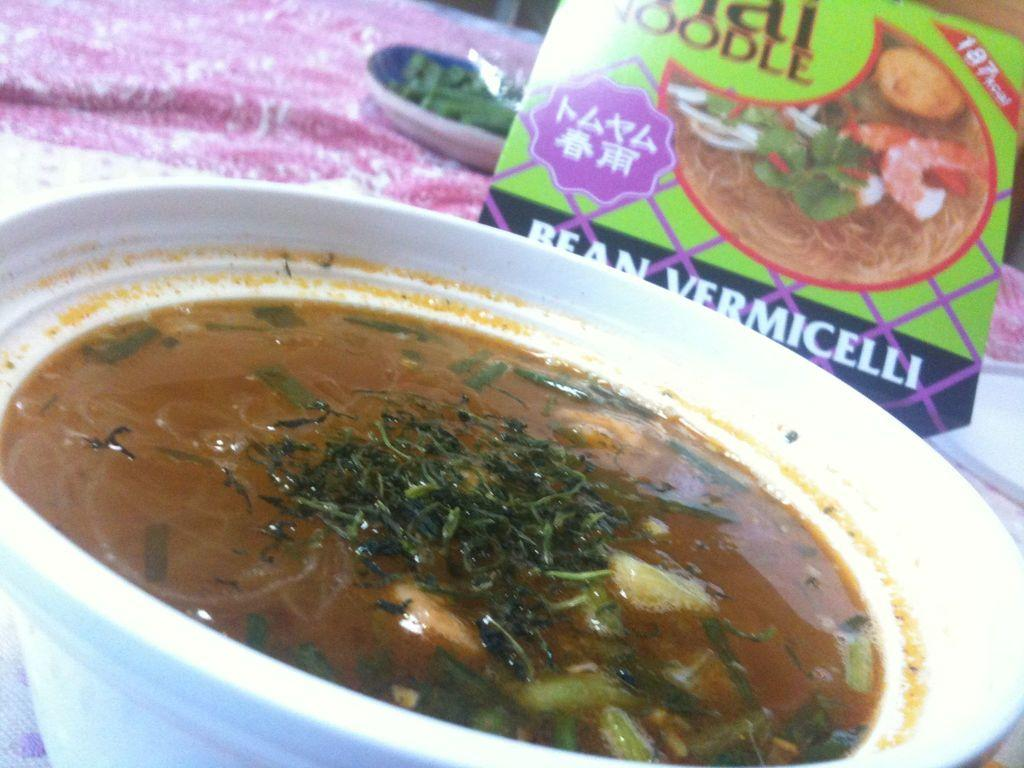What is the food item served in the image? The food item served in the container cannot be identified from the provided facts. What type of cloth is visible in the image? The type of cloth cannot be identified from the provided facts. What is the purpose of the box in the image? The purpose of the box cannot be identified from the provided facts. Can you describe the objects in the background of the image? The objects in the background cannot be identified from the provided facts. How many cats are sitting on the tank in the image? There are no cats or tanks present in the image. What type of birds can be seen flying in the background of the image? There are no birds visible in the image. 